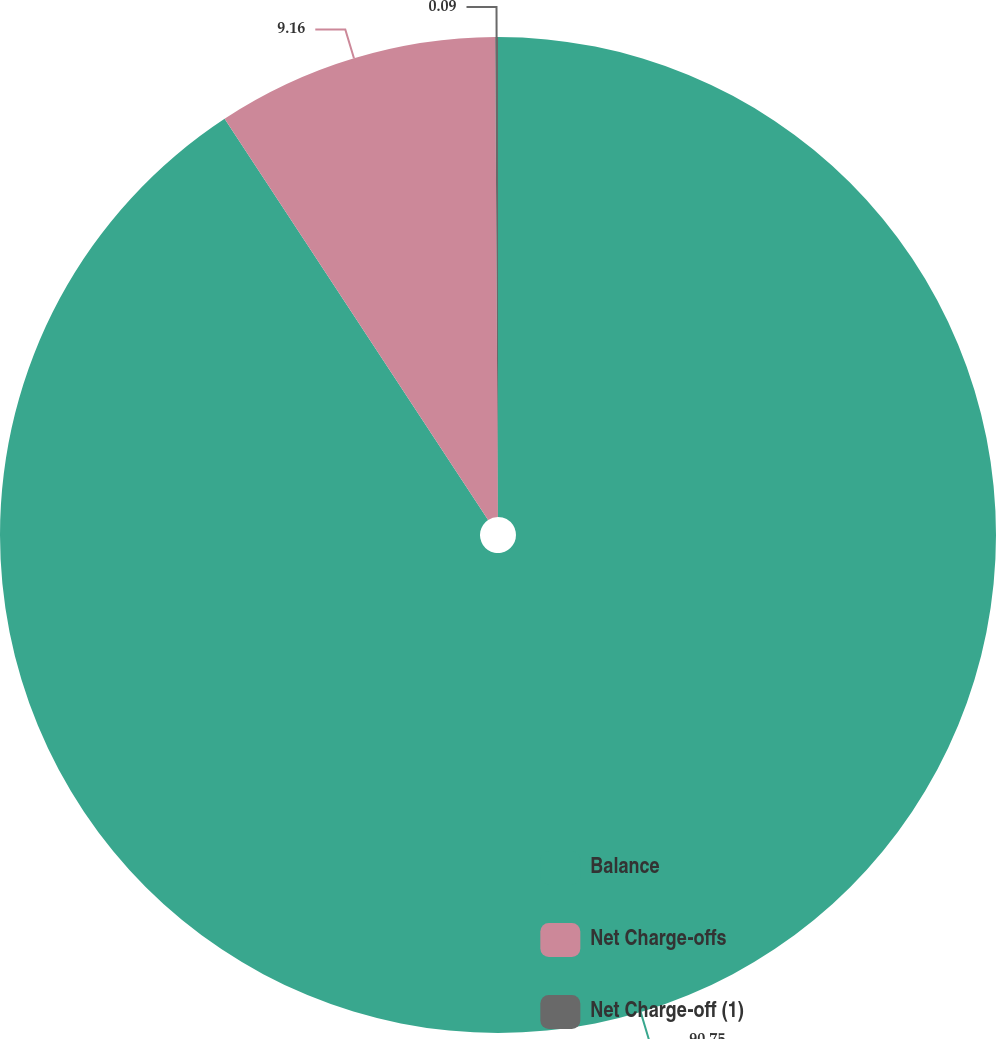Convert chart to OTSL. <chart><loc_0><loc_0><loc_500><loc_500><pie_chart><fcel>Balance<fcel>Net Charge-offs<fcel>Net Charge-off (1)<nl><fcel>90.75%<fcel>9.16%<fcel>0.09%<nl></chart> 